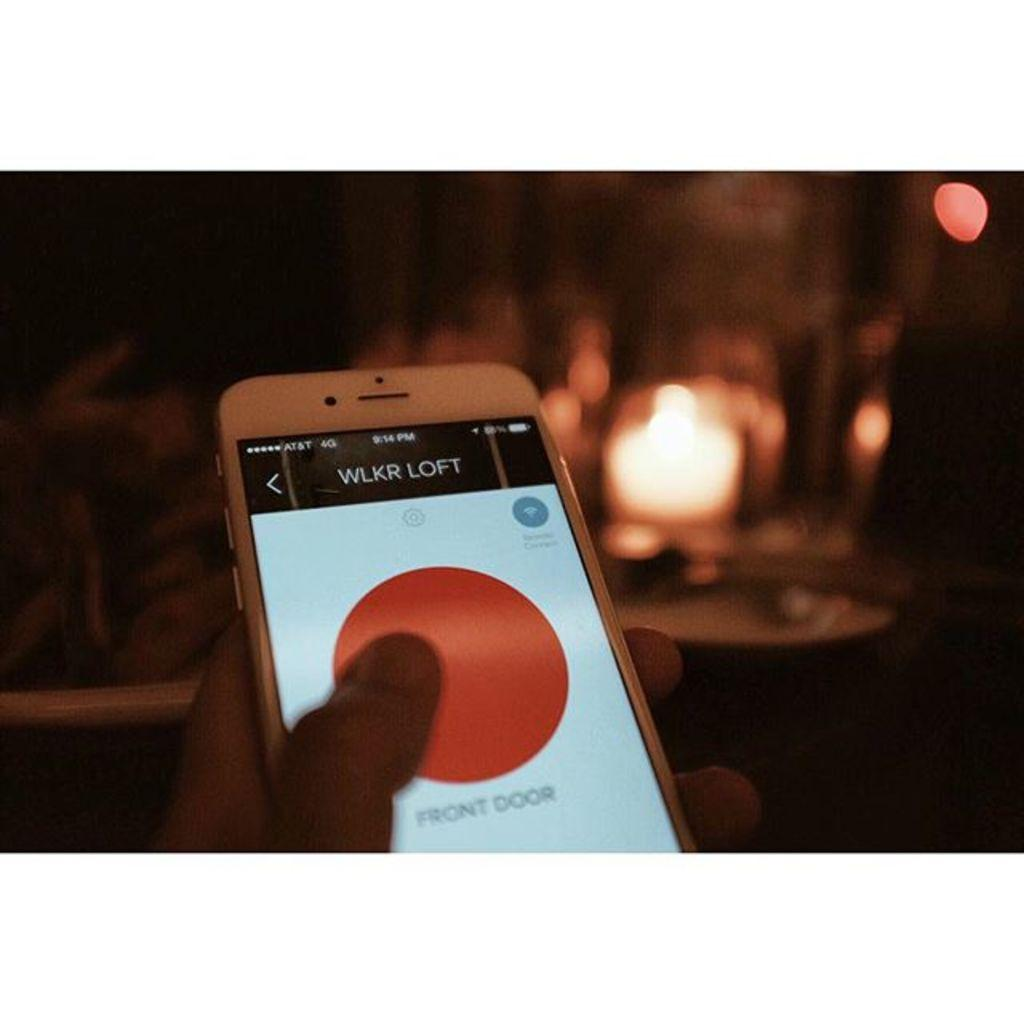<image>
Provide a brief description of the given image. A phone shows a big red circle on its display with Front Door below it. 